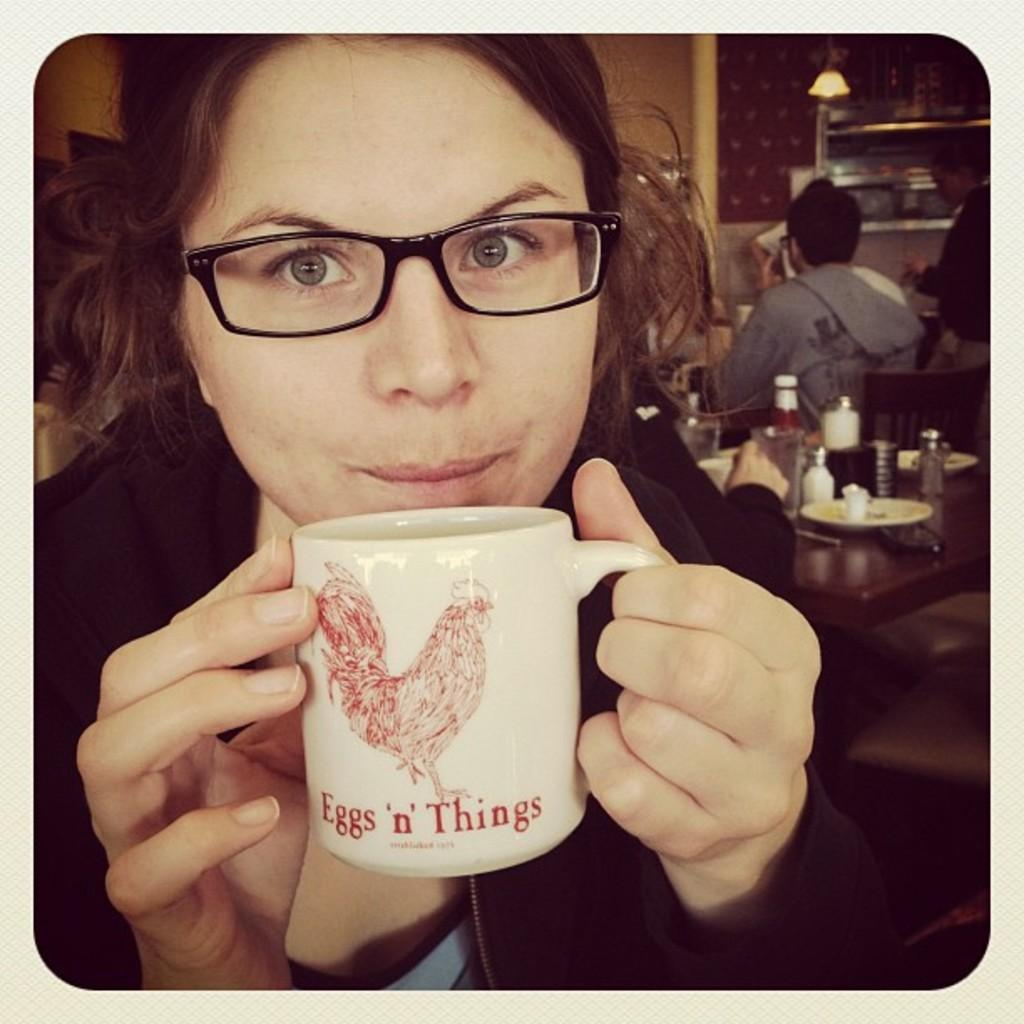<image>
Relay a brief, clear account of the picture shown. A young woman holds an Eggs 'n' Things mug up close to her mouth. 